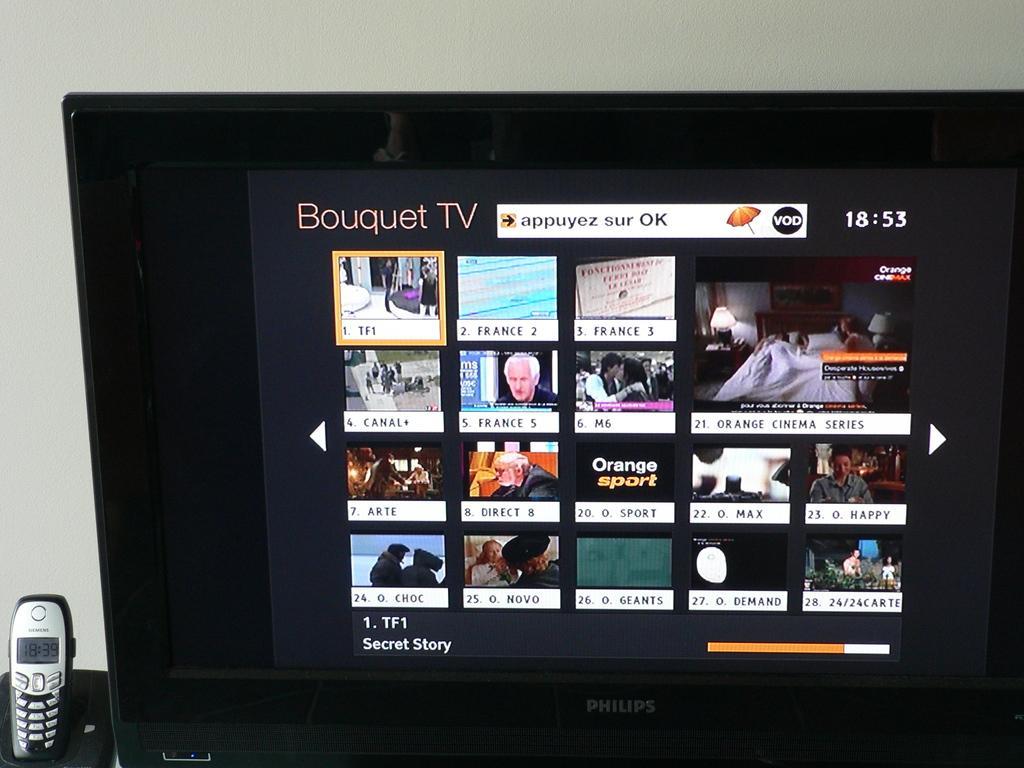Can you describe this image briefly? This picture contains a television, which is placed on the table. We even see a mobile phone placed on that table. We see something is displayed on the television. Behind that, we see a wall which is white in color. 